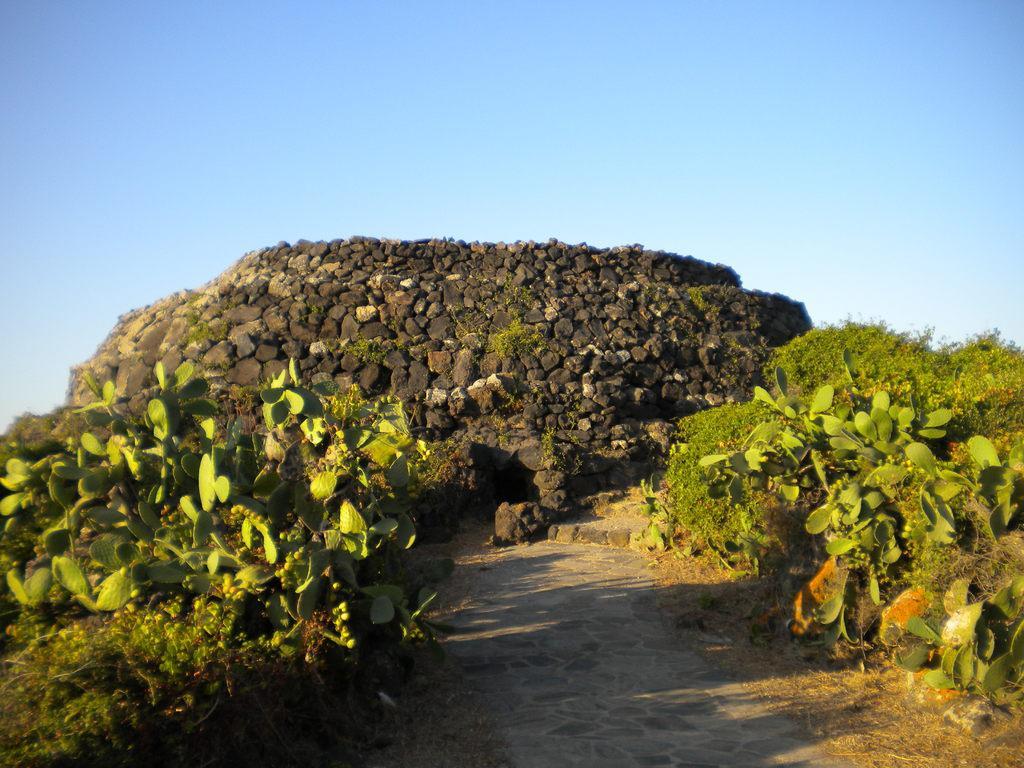Can you describe this image briefly? This picture shows few trees on the either side of the path and we see a cave made with stones and we see a blue sky. 